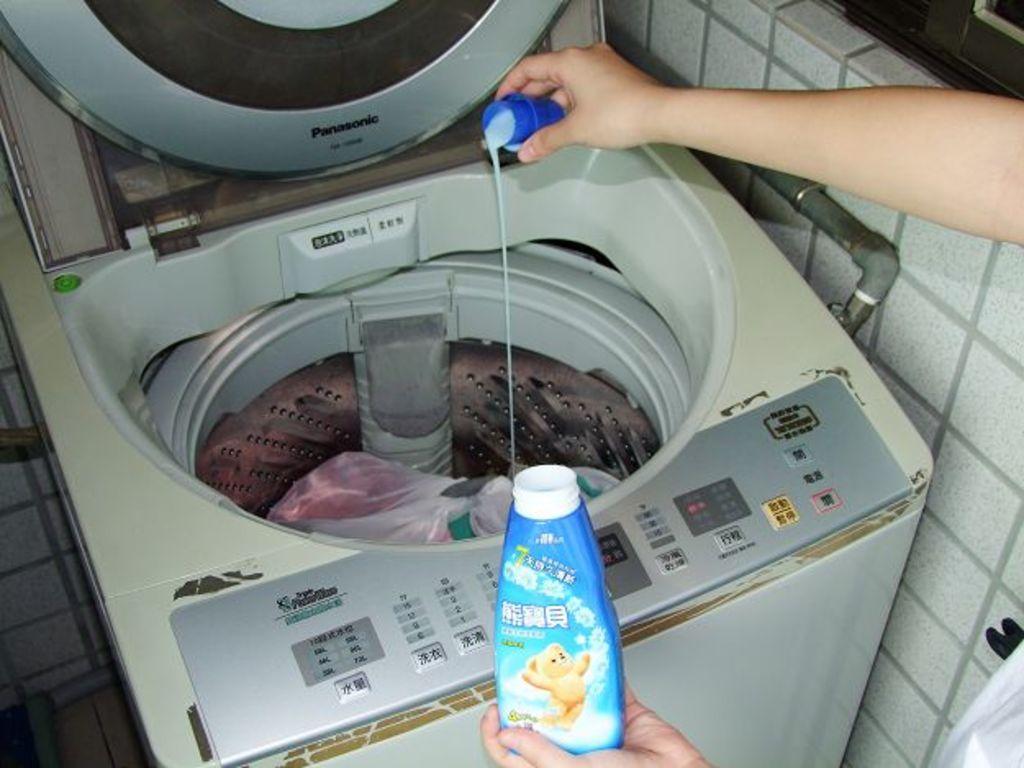Can you describe this image briefly? In this image I see a washing machine and a person's hand who is holding a bottle and a cap, I can also see the wall. 